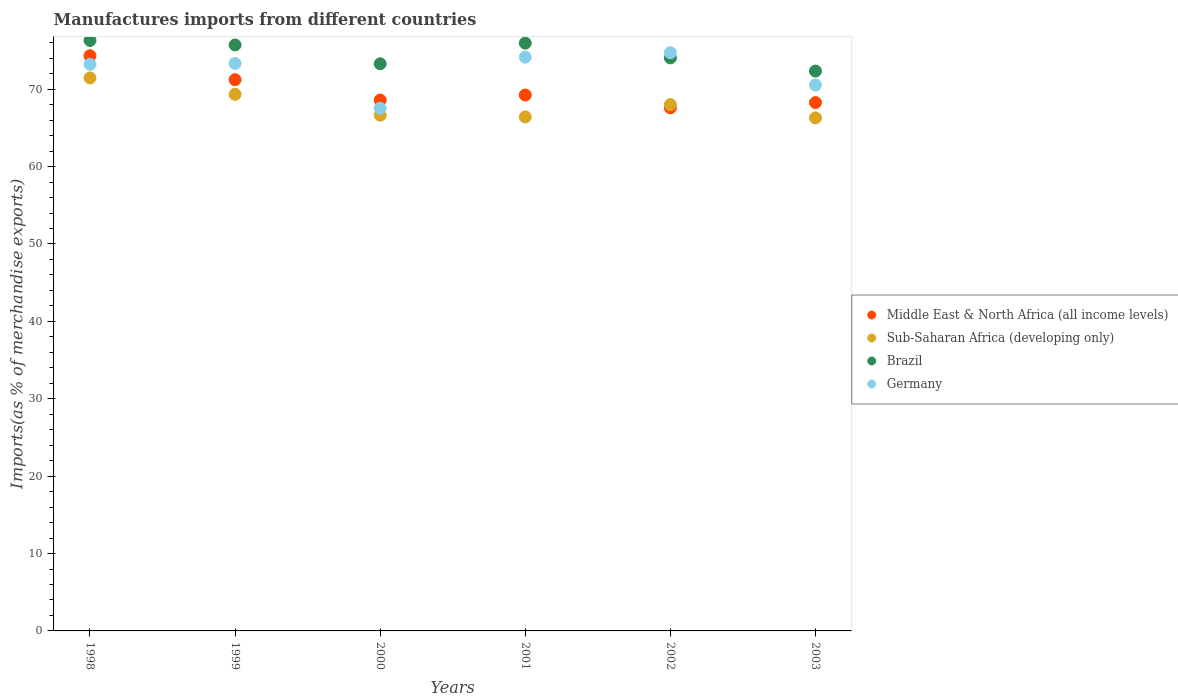What is the percentage of imports to different countries in Middle East & North Africa (all income levels) in 2002?
Your answer should be very brief. 67.6. Across all years, what is the maximum percentage of imports to different countries in Sub-Saharan Africa (developing only)?
Your answer should be compact. 71.45. Across all years, what is the minimum percentage of imports to different countries in Sub-Saharan Africa (developing only)?
Offer a terse response. 66.3. What is the total percentage of imports to different countries in Sub-Saharan Africa (developing only) in the graph?
Offer a very short reply. 408.17. What is the difference between the percentage of imports to different countries in Brazil in 2002 and that in 2003?
Your answer should be compact. 1.71. What is the difference between the percentage of imports to different countries in Sub-Saharan Africa (developing only) in 2002 and the percentage of imports to different countries in Germany in 2000?
Offer a terse response. 0.47. What is the average percentage of imports to different countries in Sub-Saharan Africa (developing only) per year?
Keep it short and to the point. 68.03. In the year 2002, what is the difference between the percentage of imports to different countries in Sub-Saharan Africa (developing only) and percentage of imports to different countries in Brazil?
Give a very brief answer. -6.04. What is the ratio of the percentage of imports to different countries in Brazil in 2002 to that in 2003?
Give a very brief answer. 1.02. Is the percentage of imports to different countries in Middle East & North Africa (all income levels) in 1998 less than that in 1999?
Keep it short and to the point. No. Is the difference between the percentage of imports to different countries in Sub-Saharan Africa (developing only) in 1999 and 2003 greater than the difference between the percentage of imports to different countries in Brazil in 1999 and 2003?
Offer a terse response. No. What is the difference between the highest and the second highest percentage of imports to different countries in Middle East & North Africa (all income levels)?
Offer a terse response. 3.1. What is the difference between the highest and the lowest percentage of imports to different countries in Germany?
Provide a short and direct response. 7.18. In how many years, is the percentage of imports to different countries in Sub-Saharan Africa (developing only) greater than the average percentage of imports to different countries in Sub-Saharan Africa (developing only) taken over all years?
Your answer should be compact. 2. Is it the case that in every year, the sum of the percentage of imports to different countries in Middle East & North Africa (all income levels) and percentage of imports to different countries in Brazil  is greater than the sum of percentage of imports to different countries in Sub-Saharan Africa (developing only) and percentage of imports to different countries in Germany?
Keep it short and to the point. No. Is it the case that in every year, the sum of the percentage of imports to different countries in Middle East & North Africa (all income levels) and percentage of imports to different countries in Germany  is greater than the percentage of imports to different countries in Sub-Saharan Africa (developing only)?
Offer a very short reply. Yes. Is the percentage of imports to different countries in Sub-Saharan Africa (developing only) strictly less than the percentage of imports to different countries in Middle East & North Africa (all income levels) over the years?
Give a very brief answer. No. How many years are there in the graph?
Provide a succinct answer. 6. Does the graph contain any zero values?
Your answer should be compact. No. Does the graph contain grids?
Provide a succinct answer. No. Where does the legend appear in the graph?
Offer a terse response. Center right. How are the legend labels stacked?
Provide a succinct answer. Vertical. What is the title of the graph?
Provide a succinct answer. Manufactures imports from different countries. What is the label or title of the Y-axis?
Provide a succinct answer. Imports(as % of merchandise exports). What is the Imports(as % of merchandise exports) in Middle East & North Africa (all income levels) in 1998?
Provide a short and direct response. 74.33. What is the Imports(as % of merchandise exports) in Sub-Saharan Africa (developing only) in 1998?
Ensure brevity in your answer.  71.45. What is the Imports(as % of merchandise exports) in Brazil in 1998?
Make the answer very short. 76.3. What is the Imports(as % of merchandise exports) of Germany in 1998?
Offer a very short reply. 73.22. What is the Imports(as % of merchandise exports) in Middle East & North Africa (all income levels) in 1999?
Your answer should be compact. 71.23. What is the Imports(as % of merchandise exports) of Sub-Saharan Africa (developing only) in 1999?
Provide a succinct answer. 69.34. What is the Imports(as % of merchandise exports) of Brazil in 1999?
Offer a terse response. 75.72. What is the Imports(as % of merchandise exports) of Germany in 1999?
Your answer should be compact. 73.33. What is the Imports(as % of merchandise exports) of Middle East & North Africa (all income levels) in 2000?
Ensure brevity in your answer.  68.6. What is the Imports(as % of merchandise exports) in Sub-Saharan Africa (developing only) in 2000?
Ensure brevity in your answer.  66.65. What is the Imports(as % of merchandise exports) in Brazil in 2000?
Provide a succinct answer. 73.29. What is the Imports(as % of merchandise exports) in Germany in 2000?
Give a very brief answer. 67.54. What is the Imports(as % of merchandise exports) in Middle East & North Africa (all income levels) in 2001?
Offer a terse response. 69.25. What is the Imports(as % of merchandise exports) in Sub-Saharan Africa (developing only) in 2001?
Offer a terse response. 66.42. What is the Imports(as % of merchandise exports) in Brazil in 2001?
Give a very brief answer. 75.96. What is the Imports(as % of merchandise exports) of Germany in 2001?
Your answer should be very brief. 74.15. What is the Imports(as % of merchandise exports) of Middle East & North Africa (all income levels) in 2002?
Ensure brevity in your answer.  67.6. What is the Imports(as % of merchandise exports) of Sub-Saharan Africa (developing only) in 2002?
Provide a succinct answer. 68.01. What is the Imports(as % of merchandise exports) in Brazil in 2002?
Make the answer very short. 74.05. What is the Imports(as % of merchandise exports) in Germany in 2002?
Your answer should be compact. 74.72. What is the Imports(as % of merchandise exports) of Middle East & North Africa (all income levels) in 2003?
Your answer should be very brief. 68.27. What is the Imports(as % of merchandise exports) of Sub-Saharan Africa (developing only) in 2003?
Provide a succinct answer. 66.3. What is the Imports(as % of merchandise exports) of Brazil in 2003?
Offer a very short reply. 72.35. What is the Imports(as % of merchandise exports) in Germany in 2003?
Keep it short and to the point. 70.54. Across all years, what is the maximum Imports(as % of merchandise exports) of Middle East & North Africa (all income levels)?
Your response must be concise. 74.33. Across all years, what is the maximum Imports(as % of merchandise exports) of Sub-Saharan Africa (developing only)?
Your response must be concise. 71.45. Across all years, what is the maximum Imports(as % of merchandise exports) in Brazil?
Offer a terse response. 76.3. Across all years, what is the maximum Imports(as % of merchandise exports) of Germany?
Keep it short and to the point. 74.72. Across all years, what is the minimum Imports(as % of merchandise exports) of Middle East & North Africa (all income levels)?
Your response must be concise. 67.6. Across all years, what is the minimum Imports(as % of merchandise exports) of Sub-Saharan Africa (developing only)?
Give a very brief answer. 66.3. Across all years, what is the minimum Imports(as % of merchandise exports) in Brazil?
Provide a short and direct response. 72.35. Across all years, what is the minimum Imports(as % of merchandise exports) of Germany?
Ensure brevity in your answer.  67.54. What is the total Imports(as % of merchandise exports) in Middle East & North Africa (all income levels) in the graph?
Give a very brief answer. 419.29. What is the total Imports(as % of merchandise exports) in Sub-Saharan Africa (developing only) in the graph?
Ensure brevity in your answer.  408.17. What is the total Imports(as % of merchandise exports) in Brazil in the graph?
Offer a terse response. 447.67. What is the total Imports(as % of merchandise exports) in Germany in the graph?
Ensure brevity in your answer.  433.5. What is the difference between the Imports(as % of merchandise exports) of Middle East & North Africa (all income levels) in 1998 and that in 1999?
Offer a terse response. 3.1. What is the difference between the Imports(as % of merchandise exports) in Sub-Saharan Africa (developing only) in 1998 and that in 1999?
Your response must be concise. 2.12. What is the difference between the Imports(as % of merchandise exports) of Brazil in 1998 and that in 1999?
Give a very brief answer. 0.58. What is the difference between the Imports(as % of merchandise exports) of Germany in 1998 and that in 1999?
Ensure brevity in your answer.  -0.11. What is the difference between the Imports(as % of merchandise exports) of Middle East & North Africa (all income levels) in 1998 and that in 2000?
Ensure brevity in your answer.  5.73. What is the difference between the Imports(as % of merchandise exports) of Sub-Saharan Africa (developing only) in 1998 and that in 2000?
Provide a succinct answer. 4.81. What is the difference between the Imports(as % of merchandise exports) in Brazil in 1998 and that in 2000?
Keep it short and to the point. 3.01. What is the difference between the Imports(as % of merchandise exports) of Germany in 1998 and that in 2000?
Offer a very short reply. 5.68. What is the difference between the Imports(as % of merchandise exports) in Middle East & North Africa (all income levels) in 1998 and that in 2001?
Offer a very short reply. 5.08. What is the difference between the Imports(as % of merchandise exports) in Sub-Saharan Africa (developing only) in 1998 and that in 2001?
Your answer should be compact. 5.03. What is the difference between the Imports(as % of merchandise exports) of Brazil in 1998 and that in 2001?
Offer a terse response. 0.35. What is the difference between the Imports(as % of merchandise exports) in Germany in 1998 and that in 2001?
Your answer should be very brief. -0.93. What is the difference between the Imports(as % of merchandise exports) of Middle East & North Africa (all income levels) in 1998 and that in 2002?
Keep it short and to the point. 6.73. What is the difference between the Imports(as % of merchandise exports) of Sub-Saharan Africa (developing only) in 1998 and that in 2002?
Keep it short and to the point. 3.44. What is the difference between the Imports(as % of merchandise exports) of Brazil in 1998 and that in 2002?
Keep it short and to the point. 2.25. What is the difference between the Imports(as % of merchandise exports) of Germany in 1998 and that in 2002?
Make the answer very short. -1.49. What is the difference between the Imports(as % of merchandise exports) of Middle East & North Africa (all income levels) in 1998 and that in 2003?
Make the answer very short. 6.05. What is the difference between the Imports(as % of merchandise exports) of Sub-Saharan Africa (developing only) in 1998 and that in 2003?
Your response must be concise. 5.16. What is the difference between the Imports(as % of merchandise exports) in Brazil in 1998 and that in 2003?
Keep it short and to the point. 3.96. What is the difference between the Imports(as % of merchandise exports) of Germany in 1998 and that in 2003?
Offer a terse response. 2.68. What is the difference between the Imports(as % of merchandise exports) in Middle East & North Africa (all income levels) in 1999 and that in 2000?
Your answer should be very brief. 2.63. What is the difference between the Imports(as % of merchandise exports) in Sub-Saharan Africa (developing only) in 1999 and that in 2000?
Make the answer very short. 2.69. What is the difference between the Imports(as % of merchandise exports) in Brazil in 1999 and that in 2000?
Your answer should be compact. 2.43. What is the difference between the Imports(as % of merchandise exports) of Germany in 1999 and that in 2000?
Give a very brief answer. 5.8. What is the difference between the Imports(as % of merchandise exports) in Middle East & North Africa (all income levels) in 1999 and that in 2001?
Your answer should be very brief. 1.98. What is the difference between the Imports(as % of merchandise exports) in Sub-Saharan Africa (developing only) in 1999 and that in 2001?
Make the answer very short. 2.92. What is the difference between the Imports(as % of merchandise exports) in Brazil in 1999 and that in 2001?
Ensure brevity in your answer.  -0.23. What is the difference between the Imports(as % of merchandise exports) in Germany in 1999 and that in 2001?
Your answer should be very brief. -0.82. What is the difference between the Imports(as % of merchandise exports) in Middle East & North Africa (all income levels) in 1999 and that in 2002?
Make the answer very short. 3.63. What is the difference between the Imports(as % of merchandise exports) in Sub-Saharan Africa (developing only) in 1999 and that in 2002?
Ensure brevity in your answer.  1.33. What is the difference between the Imports(as % of merchandise exports) in Brazil in 1999 and that in 2002?
Your answer should be very brief. 1.67. What is the difference between the Imports(as % of merchandise exports) in Germany in 1999 and that in 2002?
Offer a very short reply. -1.38. What is the difference between the Imports(as % of merchandise exports) in Middle East & North Africa (all income levels) in 1999 and that in 2003?
Provide a short and direct response. 2.95. What is the difference between the Imports(as % of merchandise exports) of Sub-Saharan Africa (developing only) in 1999 and that in 2003?
Give a very brief answer. 3.04. What is the difference between the Imports(as % of merchandise exports) of Brazil in 1999 and that in 2003?
Keep it short and to the point. 3.38. What is the difference between the Imports(as % of merchandise exports) of Germany in 1999 and that in 2003?
Give a very brief answer. 2.8. What is the difference between the Imports(as % of merchandise exports) in Middle East & North Africa (all income levels) in 2000 and that in 2001?
Your answer should be compact. -0.65. What is the difference between the Imports(as % of merchandise exports) of Sub-Saharan Africa (developing only) in 2000 and that in 2001?
Provide a succinct answer. 0.23. What is the difference between the Imports(as % of merchandise exports) of Brazil in 2000 and that in 2001?
Make the answer very short. -2.67. What is the difference between the Imports(as % of merchandise exports) of Germany in 2000 and that in 2001?
Offer a terse response. -6.61. What is the difference between the Imports(as % of merchandise exports) in Sub-Saharan Africa (developing only) in 2000 and that in 2002?
Your answer should be compact. -1.37. What is the difference between the Imports(as % of merchandise exports) of Brazil in 2000 and that in 2002?
Your response must be concise. -0.76. What is the difference between the Imports(as % of merchandise exports) of Germany in 2000 and that in 2002?
Ensure brevity in your answer.  -7.18. What is the difference between the Imports(as % of merchandise exports) in Middle East & North Africa (all income levels) in 2000 and that in 2003?
Offer a very short reply. 0.33. What is the difference between the Imports(as % of merchandise exports) of Sub-Saharan Africa (developing only) in 2000 and that in 2003?
Your answer should be very brief. 0.35. What is the difference between the Imports(as % of merchandise exports) in Brazil in 2000 and that in 2003?
Provide a short and direct response. 0.94. What is the difference between the Imports(as % of merchandise exports) of Germany in 2000 and that in 2003?
Provide a short and direct response. -3. What is the difference between the Imports(as % of merchandise exports) of Middle East & North Africa (all income levels) in 2001 and that in 2002?
Make the answer very short. 1.65. What is the difference between the Imports(as % of merchandise exports) of Sub-Saharan Africa (developing only) in 2001 and that in 2002?
Ensure brevity in your answer.  -1.59. What is the difference between the Imports(as % of merchandise exports) of Brazil in 2001 and that in 2002?
Provide a short and direct response. 1.9. What is the difference between the Imports(as % of merchandise exports) in Germany in 2001 and that in 2002?
Make the answer very short. -0.56. What is the difference between the Imports(as % of merchandise exports) in Middle East & North Africa (all income levels) in 2001 and that in 2003?
Ensure brevity in your answer.  0.98. What is the difference between the Imports(as % of merchandise exports) in Sub-Saharan Africa (developing only) in 2001 and that in 2003?
Provide a succinct answer. 0.12. What is the difference between the Imports(as % of merchandise exports) in Brazil in 2001 and that in 2003?
Make the answer very short. 3.61. What is the difference between the Imports(as % of merchandise exports) in Germany in 2001 and that in 2003?
Your response must be concise. 3.62. What is the difference between the Imports(as % of merchandise exports) of Middle East & North Africa (all income levels) in 2002 and that in 2003?
Your response must be concise. -0.67. What is the difference between the Imports(as % of merchandise exports) of Sub-Saharan Africa (developing only) in 2002 and that in 2003?
Make the answer very short. 1.72. What is the difference between the Imports(as % of merchandise exports) of Brazil in 2002 and that in 2003?
Ensure brevity in your answer.  1.71. What is the difference between the Imports(as % of merchandise exports) of Germany in 2002 and that in 2003?
Keep it short and to the point. 4.18. What is the difference between the Imports(as % of merchandise exports) in Middle East & North Africa (all income levels) in 1998 and the Imports(as % of merchandise exports) in Sub-Saharan Africa (developing only) in 1999?
Keep it short and to the point. 4.99. What is the difference between the Imports(as % of merchandise exports) of Middle East & North Africa (all income levels) in 1998 and the Imports(as % of merchandise exports) of Brazil in 1999?
Make the answer very short. -1.39. What is the difference between the Imports(as % of merchandise exports) of Sub-Saharan Africa (developing only) in 1998 and the Imports(as % of merchandise exports) of Brazil in 1999?
Keep it short and to the point. -4.27. What is the difference between the Imports(as % of merchandise exports) of Sub-Saharan Africa (developing only) in 1998 and the Imports(as % of merchandise exports) of Germany in 1999?
Your answer should be compact. -1.88. What is the difference between the Imports(as % of merchandise exports) of Brazil in 1998 and the Imports(as % of merchandise exports) of Germany in 1999?
Offer a terse response. 2.97. What is the difference between the Imports(as % of merchandise exports) of Middle East & North Africa (all income levels) in 1998 and the Imports(as % of merchandise exports) of Sub-Saharan Africa (developing only) in 2000?
Give a very brief answer. 7.68. What is the difference between the Imports(as % of merchandise exports) of Middle East & North Africa (all income levels) in 1998 and the Imports(as % of merchandise exports) of Brazil in 2000?
Keep it short and to the point. 1.04. What is the difference between the Imports(as % of merchandise exports) in Middle East & North Africa (all income levels) in 1998 and the Imports(as % of merchandise exports) in Germany in 2000?
Give a very brief answer. 6.79. What is the difference between the Imports(as % of merchandise exports) of Sub-Saharan Africa (developing only) in 1998 and the Imports(as % of merchandise exports) of Brazil in 2000?
Offer a very short reply. -1.83. What is the difference between the Imports(as % of merchandise exports) in Sub-Saharan Africa (developing only) in 1998 and the Imports(as % of merchandise exports) in Germany in 2000?
Keep it short and to the point. 3.92. What is the difference between the Imports(as % of merchandise exports) in Brazil in 1998 and the Imports(as % of merchandise exports) in Germany in 2000?
Your answer should be very brief. 8.77. What is the difference between the Imports(as % of merchandise exports) in Middle East & North Africa (all income levels) in 1998 and the Imports(as % of merchandise exports) in Sub-Saharan Africa (developing only) in 2001?
Ensure brevity in your answer.  7.91. What is the difference between the Imports(as % of merchandise exports) in Middle East & North Africa (all income levels) in 1998 and the Imports(as % of merchandise exports) in Brazil in 2001?
Make the answer very short. -1.63. What is the difference between the Imports(as % of merchandise exports) of Middle East & North Africa (all income levels) in 1998 and the Imports(as % of merchandise exports) of Germany in 2001?
Offer a terse response. 0.18. What is the difference between the Imports(as % of merchandise exports) in Sub-Saharan Africa (developing only) in 1998 and the Imports(as % of merchandise exports) in Brazil in 2001?
Keep it short and to the point. -4.5. What is the difference between the Imports(as % of merchandise exports) of Sub-Saharan Africa (developing only) in 1998 and the Imports(as % of merchandise exports) of Germany in 2001?
Keep it short and to the point. -2.7. What is the difference between the Imports(as % of merchandise exports) of Brazil in 1998 and the Imports(as % of merchandise exports) of Germany in 2001?
Your response must be concise. 2.15. What is the difference between the Imports(as % of merchandise exports) in Middle East & North Africa (all income levels) in 1998 and the Imports(as % of merchandise exports) in Sub-Saharan Africa (developing only) in 2002?
Provide a succinct answer. 6.32. What is the difference between the Imports(as % of merchandise exports) in Middle East & North Africa (all income levels) in 1998 and the Imports(as % of merchandise exports) in Brazil in 2002?
Make the answer very short. 0.28. What is the difference between the Imports(as % of merchandise exports) in Middle East & North Africa (all income levels) in 1998 and the Imports(as % of merchandise exports) in Germany in 2002?
Give a very brief answer. -0.39. What is the difference between the Imports(as % of merchandise exports) in Sub-Saharan Africa (developing only) in 1998 and the Imports(as % of merchandise exports) in Brazil in 2002?
Offer a very short reply. -2.6. What is the difference between the Imports(as % of merchandise exports) in Sub-Saharan Africa (developing only) in 1998 and the Imports(as % of merchandise exports) in Germany in 2002?
Provide a succinct answer. -3.26. What is the difference between the Imports(as % of merchandise exports) of Brazil in 1998 and the Imports(as % of merchandise exports) of Germany in 2002?
Your answer should be compact. 1.59. What is the difference between the Imports(as % of merchandise exports) of Middle East & North Africa (all income levels) in 1998 and the Imports(as % of merchandise exports) of Sub-Saharan Africa (developing only) in 2003?
Give a very brief answer. 8.03. What is the difference between the Imports(as % of merchandise exports) of Middle East & North Africa (all income levels) in 1998 and the Imports(as % of merchandise exports) of Brazil in 2003?
Provide a short and direct response. 1.98. What is the difference between the Imports(as % of merchandise exports) in Middle East & North Africa (all income levels) in 1998 and the Imports(as % of merchandise exports) in Germany in 2003?
Offer a very short reply. 3.79. What is the difference between the Imports(as % of merchandise exports) in Sub-Saharan Africa (developing only) in 1998 and the Imports(as % of merchandise exports) in Brazil in 2003?
Ensure brevity in your answer.  -0.89. What is the difference between the Imports(as % of merchandise exports) in Sub-Saharan Africa (developing only) in 1998 and the Imports(as % of merchandise exports) in Germany in 2003?
Ensure brevity in your answer.  0.92. What is the difference between the Imports(as % of merchandise exports) of Brazil in 1998 and the Imports(as % of merchandise exports) of Germany in 2003?
Make the answer very short. 5.77. What is the difference between the Imports(as % of merchandise exports) in Middle East & North Africa (all income levels) in 1999 and the Imports(as % of merchandise exports) in Sub-Saharan Africa (developing only) in 2000?
Provide a succinct answer. 4.58. What is the difference between the Imports(as % of merchandise exports) in Middle East & North Africa (all income levels) in 1999 and the Imports(as % of merchandise exports) in Brazil in 2000?
Your answer should be compact. -2.06. What is the difference between the Imports(as % of merchandise exports) of Middle East & North Africa (all income levels) in 1999 and the Imports(as % of merchandise exports) of Germany in 2000?
Your answer should be compact. 3.69. What is the difference between the Imports(as % of merchandise exports) of Sub-Saharan Africa (developing only) in 1999 and the Imports(as % of merchandise exports) of Brazil in 2000?
Offer a very short reply. -3.95. What is the difference between the Imports(as % of merchandise exports) in Sub-Saharan Africa (developing only) in 1999 and the Imports(as % of merchandise exports) in Germany in 2000?
Your response must be concise. 1.8. What is the difference between the Imports(as % of merchandise exports) of Brazil in 1999 and the Imports(as % of merchandise exports) of Germany in 2000?
Offer a very short reply. 8.18. What is the difference between the Imports(as % of merchandise exports) in Middle East & North Africa (all income levels) in 1999 and the Imports(as % of merchandise exports) in Sub-Saharan Africa (developing only) in 2001?
Offer a terse response. 4.81. What is the difference between the Imports(as % of merchandise exports) in Middle East & North Africa (all income levels) in 1999 and the Imports(as % of merchandise exports) in Brazil in 2001?
Make the answer very short. -4.73. What is the difference between the Imports(as % of merchandise exports) of Middle East & North Africa (all income levels) in 1999 and the Imports(as % of merchandise exports) of Germany in 2001?
Your answer should be very brief. -2.92. What is the difference between the Imports(as % of merchandise exports) in Sub-Saharan Africa (developing only) in 1999 and the Imports(as % of merchandise exports) in Brazil in 2001?
Make the answer very short. -6.62. What is the difference between the Imports(as % of merchandise exports) in Sub-Saharan Africa (developing only) in 1999 and the Imports(as % of merchandise exports) in Germany in 2001?
Offer a terse response. -4.81. What is the difference between the Imports(as % of merchandise exports) of Brazil in 1999 and the Imports(as % of merchandise exports) of Germany in 2001?
Give a very brief answer. 1.57. What is the difference between the Imports(as % of merchandise exports) of Middle East & North Africa (all income levels) in 1999 and the Imports(as % of merchandise exports) of Sub-Saharan Africa (developing only) in 2002?
Give a very brief answer. 3.22. What is the difference between the Imports(as % of merchandise exports) in Middle East & North Africa (all income levels) in 1999 and the Imports(as % of merchandise exports) in Brazil in 2002?
Give a very brief answer. -2.82. What is the difference between the Imports(as % of merchandise exports) in Middle East & North Africa (all income levels) in 1999 and the Imports(as % of merchandise exports) in Germany in 2002?
Offer a very short reply. -3.49. What is the difference between the Imports(as % of merchandise exports) in Sub-Saharan Africa (developing only) in 1999 and the Imports(as % of merchandise exports) in Brazil in 2002?
Offer a very short reply. -4.71. What is the difference between the Imports(as % of merchandise exports) of Sub-Saharan Africa (developing only) in 1999 and the Imports(as % of merchandise exports) of Germany in 2002?
Give a very brief answer. -5.38. What is the difference between the Imports(as % of merchandise exports) in Brazil in 1999 and the Imports(as % of merchandise exports) in Germany in 2002?
Provide a succinct answer. 1.01. What is the difference between the Imports(as % of merchandise exports) in Middle East & North Africa (all income levels) in 1999 and the Imports(as % of merchandise exports) in Sub-Saharan Africa (developing only) in 2003?
Your answer should be very brief. 4.93. What is the difference between the Imports(as % of merchandise exports) of Middle East & North Africa (all income levels) in 1999 and the Imports(as % of merchandise exports) of Brazil in 2003?
Your response must be concise. -1.12. What is the difference between the Imports(as % of merchandise exports) of Middle East & North Africa (all income levels) in 1999 and the Imports(as % of merchandise exports) of Germany in 2003?
Your answer should be compact. 0.69. What is the difference between the Imports(as % of merchandise exports) of Sub-Saharan Africa (developing only) in 1999 and the Imports(as % of merchandise exports) of Brazil in 2003?
Provide a short and direct response. -3.01. What is the difference between the Imports(as % of merchandise exports) in Sub-Saharan Africa (developing only) in 1999 and the Imports(as % of merchandise exports) in Germany in 2003?
Make the answer very short. -1.2. What is the difference between the Imports(as % of merchandise exports) in Brazil in 1999 and the Imports(as % of merchandise exports) in Germany in 2003?
Make the answer very short. 5.19. What is the difference between the Imports(as % of merchandise exports) in Middle East & North Africa (all income levels) in 2000 and the Imports(as % of merchandise exports) in Sub-Saharan Africa (developing only) in 2001?
Ensure brevity in your answer.  2.18. What is the difference between the Imports(as % of merchandise exports) of Middle East & North Africa (all income levels) in 2000 and the Imports(as % of merchandise exports) of Brazil in 2001?
Offer a very short reply. -7.35. What is the difference between the Imports(as % of merchandise exports) of Middle East & North Africa (all income levels) in 2000 and the Imports(as % of merchandise exports) of Germany in 2001?
Ensure brevity in your answer.  -5.55. What is the difference between the Imports(as % of merchandise exports) of Sub-Saharan Africa (developing only) in 2000 and the Imports(as % of merchandise exports) of Brazil in 2001?
Your answer should be compact. -9.31. What is the difference between the Imports(as % of merchandise exports) of Sub-Saharan Africa (developing only) in 2000 and the Imports(as % of merchandise exports) of Germany in 2001?
Ensure brevity in your answer.  -7.51. What is the difference between the Imports(as % of merchandise exports) in Brazil in 2000 and the Imports(as % of merchandise exports) in Germany in 2001?
Provide a short and direct response. -0.86. What is the difference between the Imports(as % of merchandise exports) of Middle East & North Africa (all income levels) in 2000 and the Imports(as % of merchandise exports) of Sub-Saharan Africa (developing only) in 2002?
Your answer should be very brief. 0.59. What is the difference between the Imports(as % of merchandise exports) in Middle East & North Africa (all income levels) in 2000 and the Imports(as % of merchandise exports) in Brazil in 2002?
Your answer should be very brief. -5.45. What is the difference between the Imports(as % of merchandise exports) of Middle East & North Africa (all income levels) in 2000 and the Imports(as % of merchandise exports) of Germany in 2002?
Provide a succinct answer. -6.11. What is the difference between the Imports(as % of merchandise exports) of Sub-Saharan Africa (developing only) in 2000 and the Imports(as % of merchandise exports) of Brazil in 2002?
Provide a short and direct response. -7.41. What is the difference between the Imports(as % of merchandise exports) in Sub-Saharan Africa (developing only) in 2000 and the Imports(as % of merchandise exports) in Germany in 2002?
Offer a terse response. -8.07. What is the difference between the Imports(as % of merchandise exports) in Brazil in 2000 and the Imports(as % of merchandise exports) in Germany in 2002?
Keep it short and to the point. -1.43. What is the difference between the Imports(as % of merchandise exports) in Middle East & North Africa (all income levels) in 2000 and the Imports(as % of merchandise exports) in Sub-Saharan Africa (developing only) in 2003?
Ensure brevity in your answer.  2.31. What is the difference between the Imports(as % of merchandise exports) in Middle East & North Africa (all income levels) in 2000 and the Imports(as % of merchandise exports) in Brazil in 2003?
Offer a very short reply. -3.74. What is the difference between the Imports(as % of merchandise exports) in Middle East & North Africa (all income levels) in 2000 and the Imports(as % of merchandise exports) in Germany in 2003?
Offer a terse response. -1.93. What is the difference between the Imports(as % of merchandise exports) of Sub-Saharan Africa (developing only) in 2000 and the Imports(as % of merchandise exports) of Brazil in 2003?
Offer a very short reply. -5.7. What is the difference between the Imports(as % of merchandise exports) of Sub-Saharan Africa (developing only) in 2000 and the Imports(as % of merchandise exports) of Germany in 2003?
Make the answer very short. -3.89. What is the difference between the Imports(as % of merchandise exports) in Brazil in 2000 and the Imports(as % of merchandise exports) in Germany in 2003?
Make the answer very short. 2.75. What is the difference between the Imports(as % of merchandise exports) of Middle East & North Africa (all income levels) in 2001 and the Imports(as % of merchandise exports) of Sub-Saharan Africa (developing only) in 2002?
Your answer should be very brief. 1.24. What is the difference between the Imports(as % of merchandise exports) in Middle East & North Africa (all income levels) in 2001 and the Imports(as % of merchandise exports) in Brazil in 2002?
Your answer should be compact. -4.8. What is the difference between the Imports(as % of merchandise exports) in Middle East & North Africa (all income levels) in 2001 and the Imports(as % of merchandise exports) in Germany in 2002?
Offer a terse response. -5.46. What is the difference between the Imports(as % of merchandise exports) of Sub-Saharan Africa (developing only) in 2001 and the Imports(as % of merchandise exports) of Brazil in 2002?
Your response must be concise. -7.63. What is the difference between the Imports(as % of merchandise exports) in Sub-Saharan Africa (developing only) in 2001 and the Imports(as % of merchandise exports) in Germany in 2002?
Give a very brief answer. -8.3. What is the difference between the Imports(as % of merchandise exports) of Brazil in 2001 and the Imports(as % of merchandise exports) of Germany in 2002?
Make the answer very short. 1.24. What is the difference between the Imports(as % of merchandise exports) of Middle East & North Africa (all income levels) in 2001 and the Imports(as % of merchandise exports) of Sub-Saharan Africa (developing only) in 2003?
Ensure brevity in your answer.  2.96. What is the difference between the Imports(as % of merchandise exports) in Middle East & North Africa (all income levels) in 2001 and the Imports(as % of merchandise exports) in Brazil in 2003?
Keep it short and to the point. -3.09. What is the difference between the Imports(as % of merchandise exports) in Middle East & North Africa (all income levels) in 2001 and the Imports(as % of merchandise exports) in Germany in 2003?
Give a very brief answer. -1.28. What is the difference between the Imports(as % of merchandise exports) in Sub-Saharan Africa (developing only) in 2001 and the Imports(as % of merchandise exports) in Brazil in 2003?
Ensure brevity in your answer.  -5.93. What is the difference between the Imports(as % of merchandise exports) in Sub-Saharan Africa (developing only) in 2001 and the Imports(as % of merchandise exports) in Germany in 2003?
Provide a succinct answer. -4.12. What is the difference between the Imports(as % of merchandise exports) in Brazil in 2001 and the Imports(as % of merchandise exports) in Germany in 2003?
Make the answer very short. 5.42. What is the difference between the Imports(as % of merchandise exports) of Middle East & North Africa (all income levels) in 2002 and the Imports(as % of merchandise exports) of Sub-Saharan Africa (developing only) in 2003?
Provide a succinct answer. 1.3. What is the difference between the Imports(as % of merchandise exports) in Middle East & North Africa (all income levels) in 2002 and the Imports(as % of merchandise exports) in Brazil in 2003?
Offer a terse response. -4.74. What is the difference between the Imports(as % of merchandise exports) in Middle East & North Africa (all income levels) in 2002 and the Imports(as % of merchandise exports) in Germany in 2003?
Provide a short and direct response. -2.93. What is the difference between the Imports(as % of merchandise exports) of Sub-Saharan Africa (developing only) in 2002 and the Imports(as % of merchandise exports) of Brazil in 2003?
Offer a very short reply. -4.33. What is the difference between the Imports(as % of merchandise exports) in Sub-Saharan Africa (developing only) in 2002 and the Imports(as % of merchandise exports) in Germany in 2003?
Keep it short and to the point. -2.52. What is the difference between the Imports(as % of merchandise exports) in Brazil in 2002 and the Imports(as % of merchandise exports) in Germany in 2003?
Provide a succinct answer. 3.52. What is the average Imports(as % of merchandise exports) of Middle East & North Africa (all income levels) per year?
Offer a very short reply. 69.88. What is the average Imports(as % of merchandise exports) in Sub-Saharan Africa (developing only) per year?
Offer a very short reply. 68.03. What is the average Imports(as % of merchandise exports) of Brazil per year?
Make the answer very short. 74.61. What is the average Imports(as % of merchandise exports) of Germany per year?
Offer a terse response. 72.25. In the year 1998, what is the difference between the Imports(as % of merchandise exports) of Middle East & North Africa (all income levels) and Imports(as % of merchandise exports) of Sub-Saharan Africa (developing only)?
Your answer should be very brief. 2.88. In the year 1998, what is the difference between the Imports(as % of merchandise exports) of Middle East & North Africa (all income levels) and Imports(as % of merchandise exports) of Brazil?
Your response must be concise. -1.97. In the year 1998, what is the difference between the Imports(as % of merchandise exports) in Middle East & North Africa (all income levels) and Imports(as % of merchandise exports) in Germany?
Give a very brief answer. 1.11. In the year 1998, what is the difference between the Imports(as % of merchandise exports) of Sub-Saharan Africa (developing only) and Imports(as % of merchandise exports) of Brazil?
Offer a terse response. -4.85. In the year 1998, what is the difference between the Imports(as % of merchandise exports) in Sub-Saharan Africa (developing only) and Imports(as % of merchandise exports) in Germany?
Keep it short and to the point. -1.77. In the year 1998, what is the difference between the Imports(as % of merchandise exports) in Brazil and Imports(as % of merchandise exports) in Germany?
Give a very brief answer. 3.08. In the year 1999, what is the difference between the Imports(as % of merchandise exports) of Middle East & North Africa (all income levels) and Imports(as % of merchandise exports) of Sub-Saharan Africa (developing only)?
Keep it short and to the point. 1.89. In the year 1999, what is the difference between the Imports(as % of merchandise exports) in Middle East & North Africa (all income levels) and Imports(as % of merchandise exports) in Brazil?
Provide a short and direct response. -4.49. In the year 1999, what is the difference between the Imports(as % of merchandise exports) in Middle East & North Africa (all income levels) and Imports(as % of merchandise exports) in Germany?
Your answer should be very brief. -2.1. In the year 1999, what is the difference between the Imports(as % of merchandise exports) in Sub-Saharan Africa (developing only) and Imports(as % of merchandise exports) in Brazil?
Offer a terse response. -6.38. In the year 1999, what is the difference between the Imports(as % of merchandise exports) in Sub-Saharan Africa (developing only) and Imports(as % of merchandise exports) in Germany?
Your response must be concise. -4. In the year 1999, what is the difference between the Imports(as % of merchandise exports) of Brazil and Imports(as % of merchandise exports) of Germany?
Offer a very short reply. 2.39. In the year 2000, what is the difference between the Imports(as % of merchandise exports) of Middle East & North Africa (all income levels) and Imports(as % of merchandise exports) of Sub-Saharan Africa (developing only)?
Offer a very short reply. 1.96. In the year 2000, what is the difference between the Imports(as % of merchandise exports) of Middle East & North Africa (all income levels) and Imports(as % of merchandise exports) of Brazil?
Your answer should be very brief. -4.69. In the year 2000, what is the difference between the Imports(as % of merchandise exports) of Middle East & North Africa (all income levels) and Imports(as % of merchandise exports) of Germany?
Give a very brief answer. 1.06. In the year 2000, what is the difference between the Imports(as % of merchandise exports) in Sub-Saharan Africa (developing only) and Imports(as % of merchandise exports) in Brazil?
Ensure brevity in your answer.  -6.64. In the year 2000, what is the difference between the Imports(as % of merchandise exports) of Sub-Saharan Africa (developing only) and Imports(as % of merchandise exports) of Germany?
Keep it short and to the point. -0.89. In the year 2000, what is the difference between the Imports(as % of merchandise exports) of Brazil and Imports(as % of merchandise exports) of Germany?
Offer a very short reply. 5.75. In the year 2001, what is the difference between the Imports(as % of merchandise exports) of Middle East & North Africa (all income levels) and Imports(as % of merchandise exports) of Sub-Saharan Africa (developing only)?
Your response must be concise. 2.83. In the year 2001, what is the difference between the Imports(as % of merchandise exports) of Middle East & North Africa (all income levels) and Imports(as % of merchandise exports) of Brazil?
Keep it short and to the point. -6.7. In the year 2001, what is the difference between the Imports(as % of merchandise exports) of Middle East & North Africa (all income levels) and Imports(as % of merchandise exports) of Germany?
Ensure brevity in your answer.  -4.9. In the year 2001, what is the difference between the Imports(as % of merchandise exports) in Sub-Saharan Africa (developing only) and Imports(as % of merchandise exports) in Brazil?
Your answer should be compact. -9.53. In the year 2001, what is the difference between the Imports(as % of merchandise exports) of Sub-Saharan Africa (developing only) and Imports(as % of merchandise exports) of Germany?
Your answer should be very brief. -7.73. In the year 2001, what is the difference between the Imports(as % of merchandise exports) of Brazil and Imports(as % of merchandise exports) of Germany?
Offer a terse response. 1.8. In the year 2002, what is the difference between the Imports(as % of merchandise exports) of Middle East & North Africa (all income levels) and Imports(as % of merchandise exports) of Sub-Saharan Africa (developing only)?
Your answer should be very brief. -0.41. In the year 2002, what is the difference between the Imports(as % of merchandise exports) of Middle East & North Africa (all income levels) and Imports(as % of merchandise exports) of Brazil?
Provide a short and direct response. -6.45. In the year 2002, what is the difference between the Imports(as % of merchandise exports) in Middle East & North Africa (all income levels) and Imports(as % of merchandise exports) in Germany?
Offer a very short reply. -7.11. In the year 2002, what is the difference between the Imports(as % of merchandise exports) in Sub-Saharan Africa (developing only) and Imports(as % of merchandise exports) in Brazil?
Provide a succinct answer. -6.04. In the year 2002, what is the difference between the Imports(as % of merchandise exports) of Sub-Saharan Africa (developing only) and Imports(as % of merchandise exports) of Germany?
Provide a succinct answer. -6.7. In the year 2002, what is the difference between the Imports(as % of merchandise exports) of Brazil and Imports(as % of merchandise exports) of Germany?
Your answer should be very brief. -0.66. In the year 2003, what is the difference between the Imports(as % of merchandise exports) in Middle East & North Africa (all income levels) and Imports(as % of merchandise exports) in Sub-Saharan Africa (developing only)?
Your response must be concise. 1.98. In the year 2003, what is the difference between the Imports(as % of merchandise exports) in Middle East & North Africa (all income levels) and Imports(as % of merchandise exports) in Brazil?
Give a very brief answer. -4.07. In the year 2003, what is the difference between the Imports(as % of merchandise exports) of Middle East & North Africa (all income levels) and Imports(as % of merchandise exports) of Germany?
Provide a short and direct response. -2.26. In the year 2003, what is the difference between the Imports(as % of merchandise exports) in Sub-Saharan Africa (developing only) and Imports(as % of merchandise exports) in Brazil?
Offer a very short reply. -6.05. In the year 2003, what is the difference between the Imports(as % of merchandise exports) in Sub-Saharan Africa (developing only) and Imports(as % of merchandise exports) in Germany?
Ensure brevity in your answer.  -4.24. In the year 2003, what is the difference between the Imports(as % of merchandise exports) of Brazil and Imports(as % of merchandise exports) of Germany?
Your answer should be compact. 1.81. What is the ratio of the Imports(as % of merchandise exports) in Middle East & North Africa (all income levels) in 1998 to that in 1999?
Keep it short and to the point. 1.04. What is the ratio of the Imports(as % of merchandise exports) of Sub-Saharan Africa (developing only) in 1998 to that in 1999?
Offer a very short reply. 1.03. What is the ratio of the Imports(as % of merchandise exports) of Brazil in 1998 to that in 1999?
Offer a terse response. 1.01. What is the ratio of the Imports(as % of merchandise exports) of Middle East & North Africa (all income levels) in 1998 to that in 2000?
Offer a terse response. 1.08. What is the ratio of the Imports(as % of merchandise exports) in Sub-Saharan Africa (developing only) in 1998 to that in 2000?
Give a very brief answer. 1.07. What is the ratio of the Imports(as % of merchandise exports) of Brazil in 1998 to that in 2000?
Your answer should be very brief. 1.04. What is the ratio of the Imports(as % of merchandise exports) in Germany in 1998 to that in 2000?
Keep it short and to the point. 1.08. What is the ratio of the Imports(as % of merchandise exports) in Middle East & North Africa (all income levels) in 1998 to that in 2001?
Give a very brief answer. 1.07. What is the ratio of the Imports(as % of merchandise exports) in Sub-Saharan Africa (developing only) in 1998 to that in 2001?
Give a very brief answer. 1.08. What is the ratio of the Imports(as % of merchandise exports) of Brazil in 1998 to that in 2001?
Your answer should be compact. 1. What is the ratio of the Imports(as % of merchandise exports) of Germany in 1998 to that in 2001?
Your response must be concise. 0.99. What is the ratio of the Imports(as % of merchandise exports) in Middle East & North Africa (all income levels) in 1998 to that in 2002?
Offer a very short reply. 1.1. What is the ratio of the Imports(as % of merchandise exports) in Sub-Saharan Africa (developing only) in 1998 to that in 2002?
Provide a short and direct response. 1.05. What is the ratio of the Imports(as % of merchandise exports) in Brazil in 1998 to that in 2002?
Provide a succinct answer. 1.03. What is the ratio of the Imports(as % of merchandise exports) in Germany in 1998 to that in 2002?
Provide a succinct answer. 0.98. What is the ratio of the Imports(as % of merchandise exports) in Middle East & North Africa (all income levels) in 1998 to that in 2003?
Your answer should be compact. 1.09. What is the ratio of the Imports(as % of merchandise exports) of Sub-Saharan Africa (developing only) in 1998 to that in 2003?
Ensure brevity in your answer.  1.08. What is the ratio of the Imports(as % of merchandise exports) of Brazil in 1998 to that in 2003?
Offer a terse response. 1.05. What is the ratio of the Imports(as % of merchandise exports) of Germany in 1998 to that in 2003?
Make the answer very short. 1.04. What is the ratio of the Imports(as % of merchandise exports) in Middle East & North Africa (all income levels) in 1999 to that in 2000?
Offer a terse response. 1.04. What is the ratio of the Imports(as % of merchandise exports) of Sub-Saharan Africa (developing only) in 1999 to that in 2000?
Provide a succinct answer. 1.04. What is the ratio of the Imports(as % of merchandise exports) in Brazil in 1999 to that in 2000?
Your answer should be compact. 1.03. What is the ratio of the Imports(as % of merchandise exports) in Germany in 1999 to that in 2000?
Ensure brevity in your answer.  1.09. What is the ratio of the Imports(as % of merchandise exports) in Middle East & North Africa (all income levels) in 1999 to that in 2001?
Your answer should be very brief. 1.03. What is the ratio of the Imports(as % of merchandise exports) in Sub-Saharan Africa (developing only) in 1999 to that in 2001?
Your answer should be compact. 1.04. What is the ratio of the Imports(as % of merchandise exports) of Germany in 1999 to that in 2001?
Provide a short and direct response. 0.99. What is the ratio of the Imports(as % of merchandise exports) of Middle East & North Africa (all income levels) in 1999 to that in 2002?
Your answer should be compact. 1.05. What is the ratio of the Imports(as % of merchandise exports) in Sub-Saharan Africa (developing only) in 1999 to that in 2002?
Offer a very short reply. 1.02. What is the ratio of the Imports(as % of merchandise exports) of Brazil in 1999 to that in 2002?
Offer a very short reply. 1.02. What is the ratio of the Imports(as % of merchandise exports) of Germany in 1999 to that in 2002?
Keep it short and to the point. 0.98. What is the ratio of the Imports(as % of merchandise exports) in Middle East & North Africa (all income levels) in 1999 to that in 2003?
Provide a succinct answer. 1.04. What is the ratio of the Imports(as % of merchandise exports) of Sub-Saharan Africa (developing only) in 1999 to that in 2003?
Keep it short and to the point. 1.05. What is the ratio of the Imports(as % of merchandise exports) of Brazil in 1999 to that in 2003?
Offer a very short reply. 1.05. What is the ratio of the Imports(as % of merchandise exports) in Germany in 1999 to that in 2003?
Provide a short and direct response. 1.04. What is the ratio of the Imports(as % of merchandise exports) of Middle East & North Africa (all income levels) in 2000 to that in 2001?
Your response must be concise. 0.99. What is the ratio of the Imports(as % of merchandise exports) of Sub-Saharan Africa (developing only) in 2000 to that in 2001?
Ensure brevity in your answer.  1. What is the ratio of the Imports(as % of merchandise exports) of Brazil in 2000 to that in 2001?
Keep it short and to the point. 0.96. What is the ratio of the Imports(as % of merchandise exports) in Germany in 2000 to that in 2001?
Your answer should be very brief. 0.91. What is the ratio of the Imports(as % of merchandise exports) of Middle East & North Africa (all income levels) in 2000 to that in 2002?
Give a very brief answer. 1.01. What is the ratio of the Imports(as % of merchandise exports) of Sub-Saharan Africa (developing only) in 2000 to that in 2002?
Your answer should be compact. 0.98. What is the ratio of the Imports(as % of merchandise exports) in Germany in 2000 to that in 2002?
Provide a succinct answer. 0.9. What is the ratio of the Imports(as % of merchandise exports) of Sub-Saharan Africa (developing only) in 2000 to that in 2003?
Ensure brevity in your answer.  1.01. What is the ratio of the Imports(as % of merchandise exports) of Germany in 2000 to that in 2003?
Make the answer very short. 0.96. What is the ratio of the Imports(as % of merchandise exports) of Middle East & North Africa (all income levels) in 2001 to that in 2002?
Provide a succinct answer. 1.02. What is the ratio of the Imports(as % of merchandise exports) of Sub-Saharan Africa (developing only) in 2001 to that in 2002?
Ensure brevity in your answer.  0.98. What is the ratio of the Imports(as % of merchandise exports) in Brazil in 2001 to that in 2002?
Provide a short and direct response. 1.03. What is the ratio of the Imports(as % of merchandise exports) in Middle East & North Africa (all income levels) in 2001 to that in 2003?
Provide a succinct answer. 1.01. What is the ratio of the Imports(as % of merchandise exports) in Brazil in 2001 to that in 2003?
Your answer should be compact. 1.05. What is the ratio of the Imports(as % of merchandise exports) in Germany in 2001 to that in 2003?
Offer a terse response. 1.05. What is the ratio of the Imports(as % of merchandise exports) in Middle East & North Africa (all income levels) in 2002 to that in 2003?
Make the answer very short. 0.99. What is the ratio of the Imports(as % of merchandise exports) of Sub-Saharan Africa (developing only) in 2002 to that in 2003?
Give a very brief answer. 1.03. What is the ratio of the Imports(as % of merchandise exports) in Brazil in 2002 to that in 2003?
Make the answer very short. 1.02. What is the ratio of the Imports(as % of merchandise exports) of Germany in 2002 to that in 2003?
Ensure brevity in your answer.  1.06. What is the difference between the highest and the second highest Imports(as % of merchandise exports) of Middle East & North Africa (all income levels)?
Ensure brevity in your answer.  3.1. What is the difference between the highest and the second highest Imports(as % of merchandise exports) in Sub-Saharan Africa (developing only)?
Provide a succinct answer. 2.12. What is the difference between the highest and the second highest Imports(as % of merchandise exports) of Brazil?
Provide a short and direct response. 0.35. What is the difference between the highest and the second highest Imports(as % of merchandise exports) in Germany?
Offer a terse response. 0.56. What is the difference between the highest and the lowest Imports(as % of merchandise exports) of Middle East & North Africa (all income levels)?
Provide a short and direct response. 6.73. What is the difference between the highest and the lowest Imports(as % of merchandise exports) in Sub-Saharan Africa (developing only)?
Provide a short and direct response. 5.16. What is the difference between the highest and the lowest Imports(as % of merchandise exports) in Brazil?
Keep it short and to the point. 3.96. What is the difference between the highest and the lowest Imports(as % of merchandise exports) in Germany?
Offer a terse response. 7.18. 